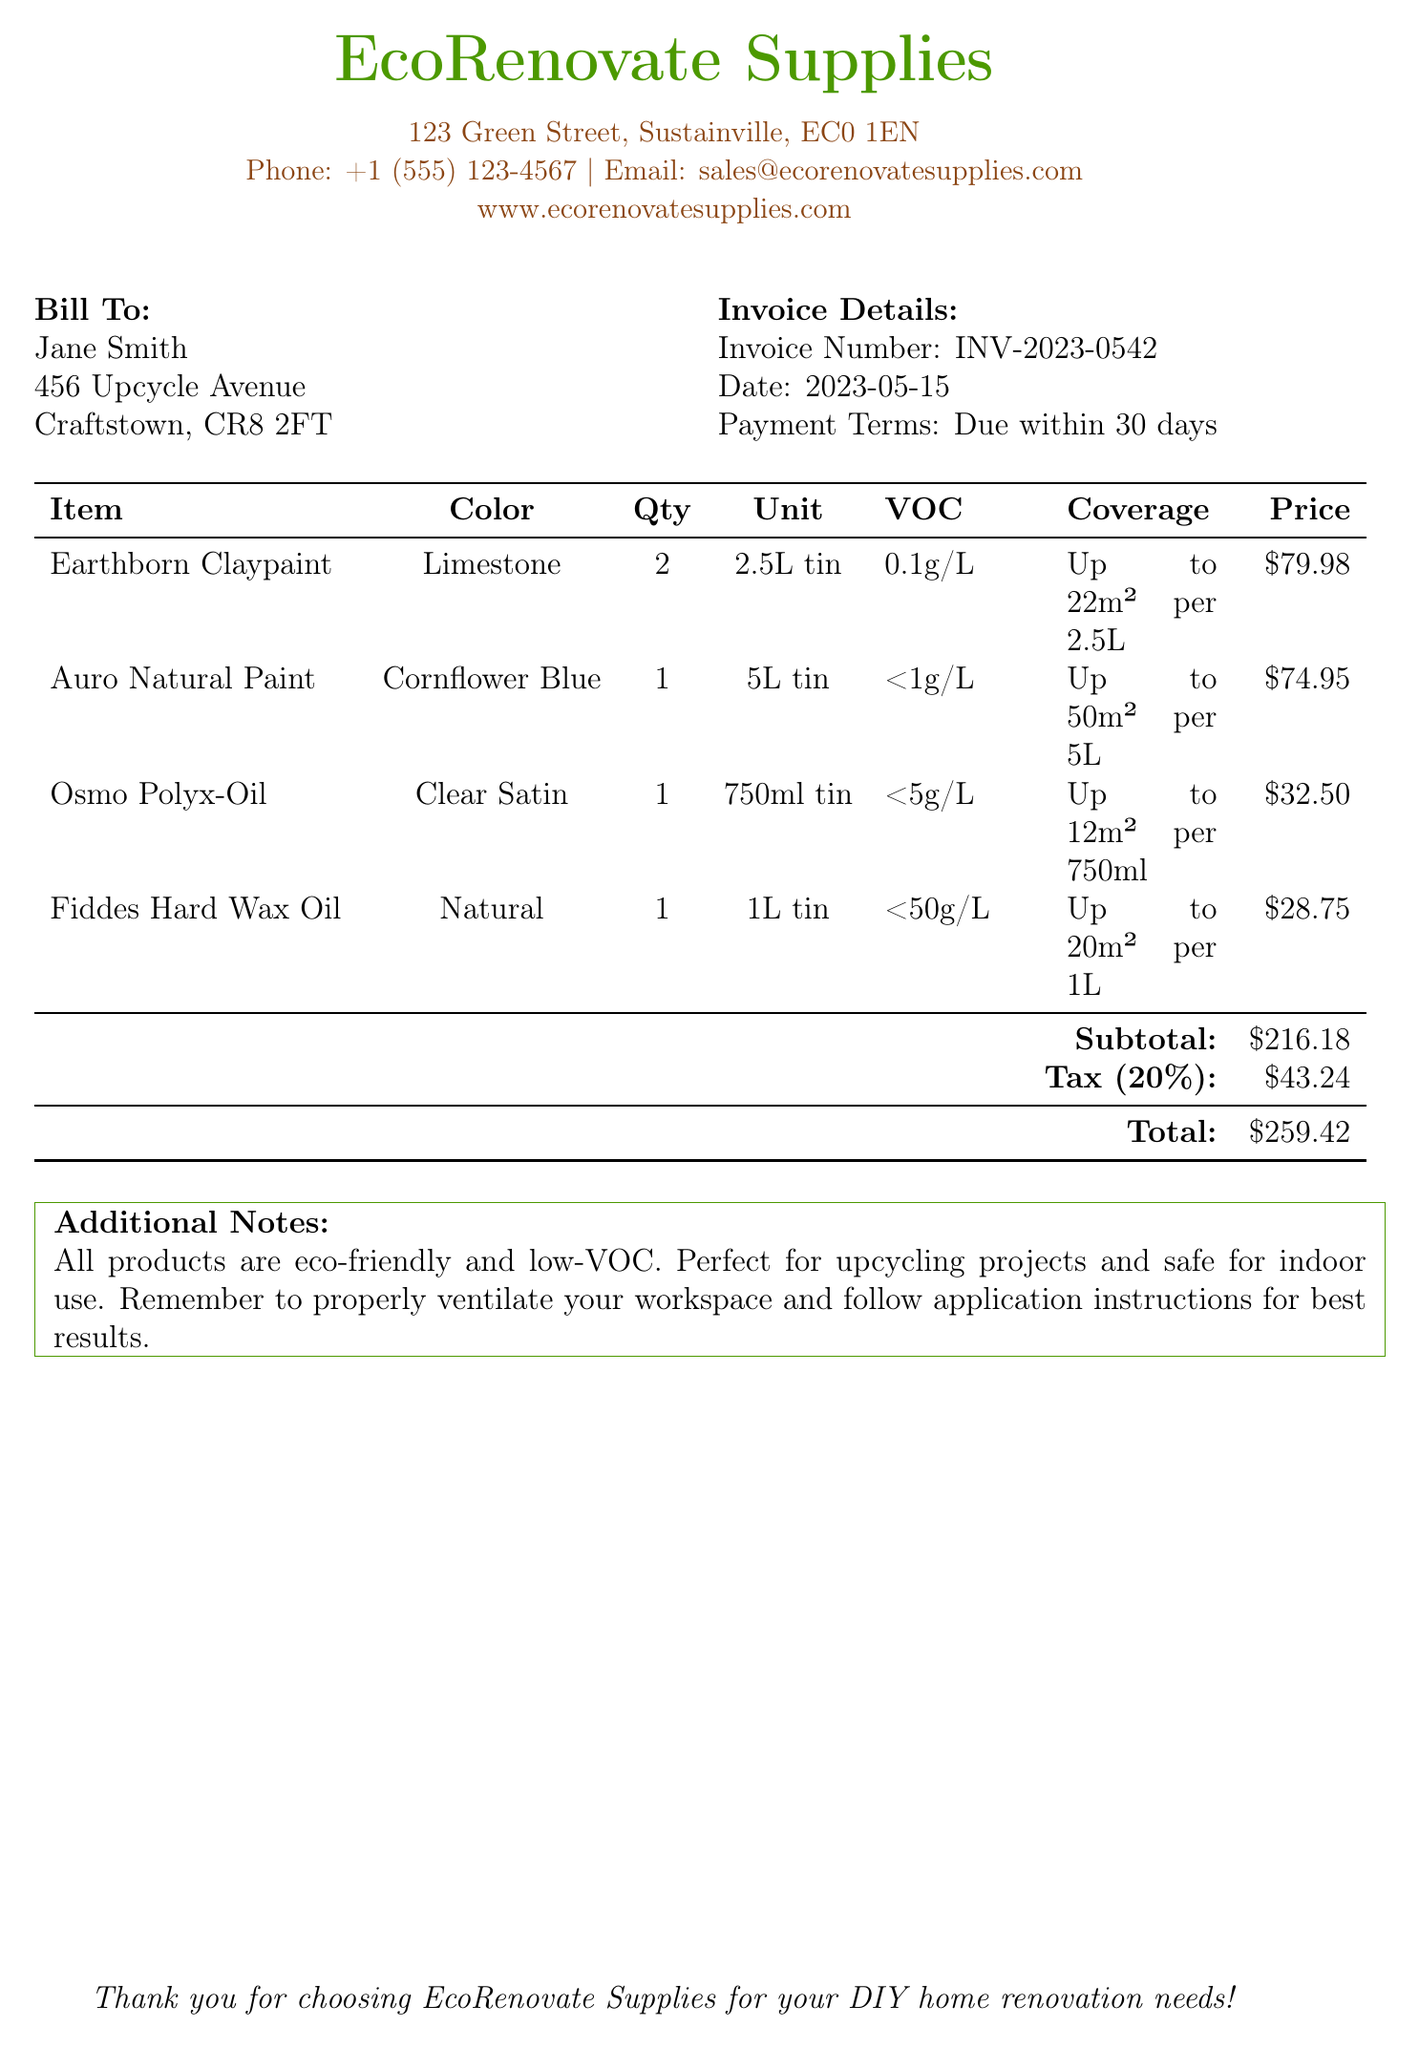What is the invoice number? The invoice number is listed in the document to identify the transaction.
Answer: INV-2023-0542 What is the total amount due? The total amount due is found at the bottom of the invoice after accounting for the subtotal and tax.
Answer: $259.42 How many liters of Earthborn Claypaint were purchased? The quantity of Earthborn Claypaint purchased is specified in the item listing.
Answer: 2 What is the VOC content of Auro Natural Paint? The VOC content for Auro Natural Paint is given in the product details.
Answer: <1g/L What is the coverage area for Fiddes Hard Wax Oil? The coverage area for Fiddes Hard Wax Oil is indicated next to the product information.
Answer: Up to 20m² per 1L What is the subtotal before tax? The subtotal is calculated from the individual item prices before tax is added.
Answer: $216.18 What color is the Osmo Polyx-Oil? The color of the Osmo Polyx-Oil is specified in the item table.
Answer: Clear Satin How many items are listed in the invoice? The number of items can be counted from the itemized list in the document.
Answer: 4 What is the payment term specified in the invoice? The payment term is mentioned in the invoice details section.
Answer: Due within 30 days 